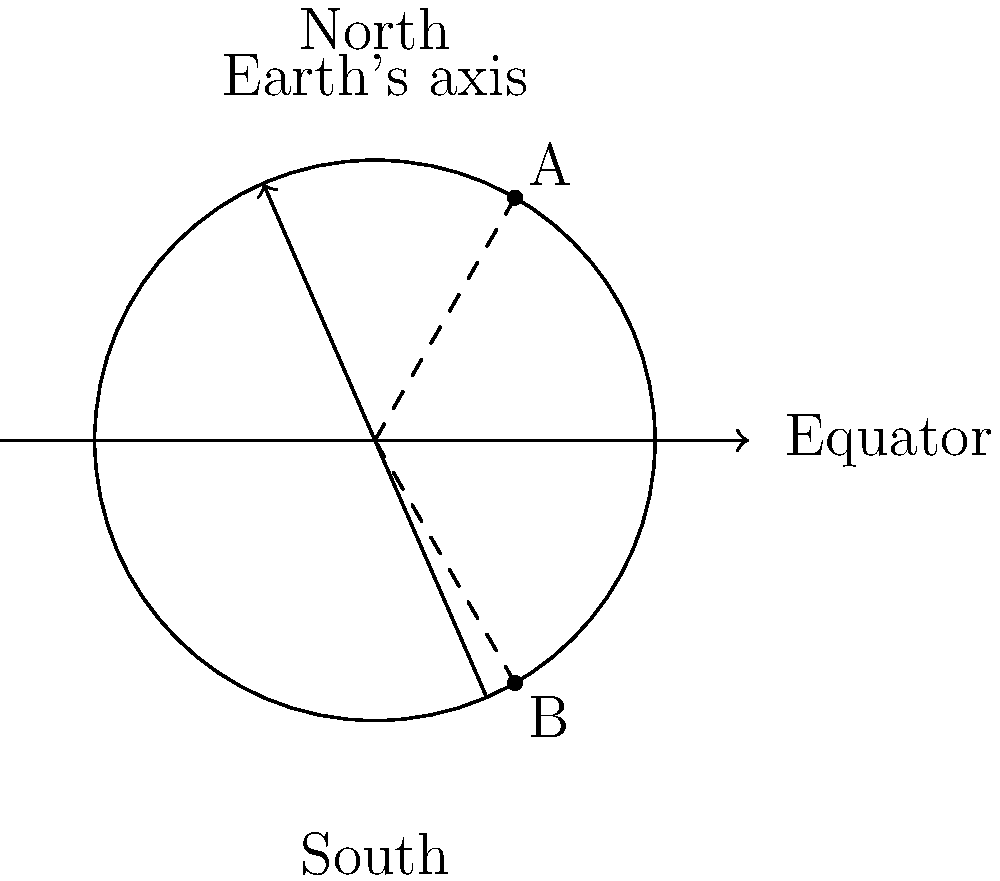As an African tribal leader collaborating with foreign diplomats, you're discussing the impact of Earth's rotation on different African regions. Using the diagram, which shows Earth tilted on its axis, explain why point A (representing a northern African location) experiences longer days during June compared to point B (a southern African location). How does this affect agricultural planning and economic activities in these regions? To understand this phenomenon, let's break it down step-by-step:

1. Earth's axis tilt: The diagram shows Earth tilted at an angle of approximately 23.5° relative to its orbital plane.

2. Northern vs Southern hemisphere:
   - Point A is in the Northern hemisphere
   - Point B is in the Southern hemisphere

3. June solstice:
   - During June, the North Pole is tilted towards the Sun
   - This causes the Northern hemisphere to receive more direct sunlight

4. Day length:
   - Point A spends more time in sunlight during each rotation
   - Point B spends less time in sunlight during each rotation

5. Reason for difference:
   - As Earth rotates, point A has a larger arc above the terminator (day/night line)
   - Point B has a smaller arc above the terminator

6. Effect on day length:
   - Longer days at point A (northern Africa)
   - Shorter days at point B (southern Africa)

7. Agricultural impact:
   - Northern regions: Longer growing seasons, more sunlight for crops
   - Southern regions: Shorter growing seasons, less sunlight for crops

8. Economic considerations:
   - Adapt crop choices and planting schedules to day length variations
   - Plan for seasonal variations in agricultural productivity
   - Consider impact on energy usage (e.g., lighting, heating/cooling)
   - Adjust work schedules and economic activities to daylight availability

Understanding these differences is crucial for effective agricultural planning and economic development across different African regions.
Answer: Earth's axial tilt causes longer June days in northern Africa (A) than southern Africa (B), affecting agricultural seasons and economic activities. 